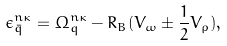<formula> <loc_0><loc_0><loc_500><loc_500>\epsilon _ { \bar { q } } ^ { n \kappa } = \Omega _ { q } ^ { n \kappa } - R _ { B } ( V _ { \omega } \pm \frac { 1 } { 2 } V _ { \rho } ) ,</formula> 